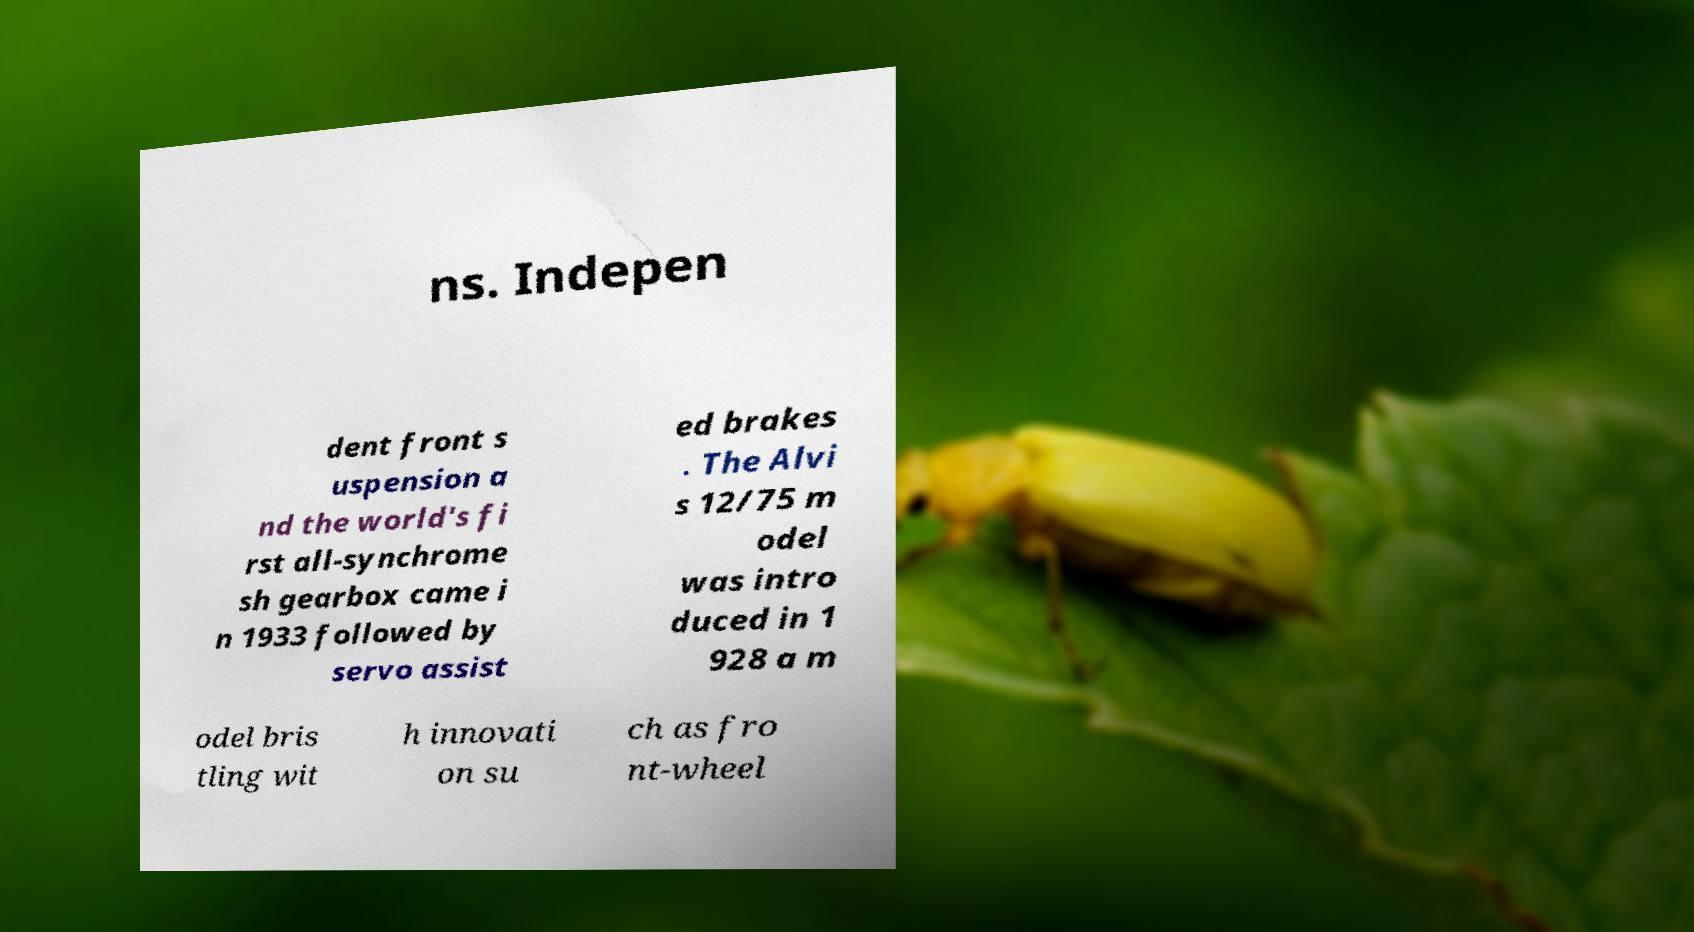I need the written content from this picture converted into text. Can you do that? ns. Indepen dent front s uspension a nd the world's fi rst all-synchrome sh gearbox came i n 1933 followed by servo assist ed brakes . The Alvi s 12/75 m odel was intro duced in 1 928 a m odel bris tling wit h innovati on su ch as fro nt-wheel 